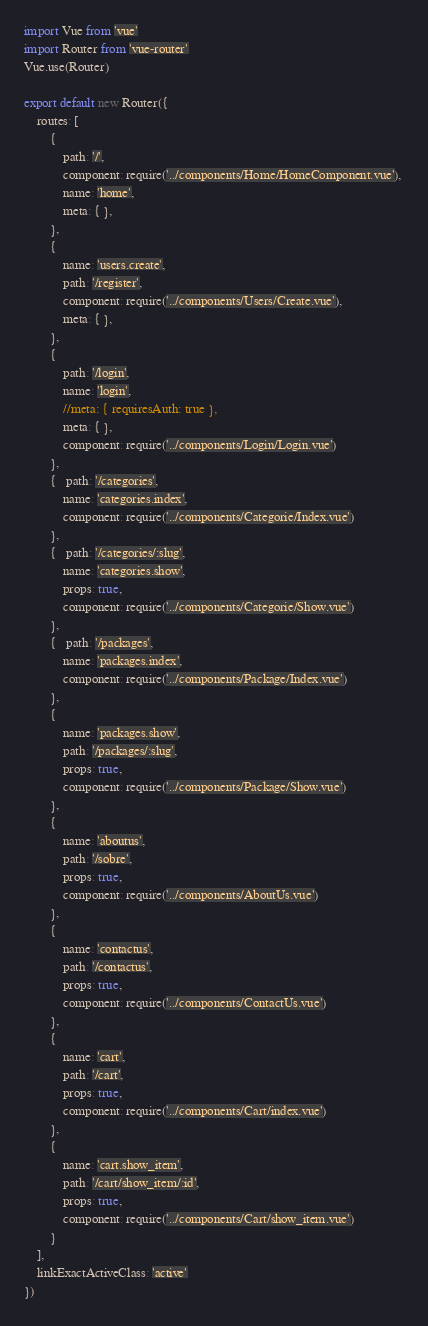<code> <loc_0><loc_0><loc_500><loc_500><_JavaScript_>import Vue from 'vue'
import Router from 'vue-router'
Vue.use(Router)

export default new Router({
  	routes: [
	    { 
	        path: '/', 
	        component: require('../components/Home/HomeComponent.vue'), 
	        name: 'home',
	        meta: { },
	    },
	    { 
	        name: 'users.create',
	        path: '/register', 
	        component: require('../components/Users/Create.vue'),
	        meta: { },
	    },
	    { 
	        path: '/login', 
	        name: 'login',
	        //meta: { requiresAuth: true },
	        meta: { },
	        component: require('../components/Login/Login.vue')
	    },
	    {   path: '/categories',
	        name: 'categories.index', 
	        component: require('../components/Categorie/Index.vue')
	    },    
	    {   path: '/categories/:slug',
	        name: 'categories.show', 
	        props: true,
	        component: require('../components/Categorie/Show.vue')
	    }, 
	    {   path: '/packages',
	        name: 'packages.index', 
	        component: require('../components/Package/Index.vue')
	    },
	    {
	        name: 'packages.show',
	        path: '/packages/:slug',
	        props: true,
	        component: require('../components/Package/Show.vue')
	    },
	    {
	        name: 'aboutus',
	        path: '/sobre',
	        props: true,
	        component: require('../components/AboutUs.vue')
	    },
	    {
	        name: 'contactus',
	        path: '/contactus',
	        props: true,
	        component: require('../components/ContactUs.vue')
	    },
	    {
	        name: 'cart',
	        path: '/cart',
	        props: true,
	        component: require('../components/Cart/index.vue')
	    },
	    {
	        name: 'cart.show_item',
	        path: '/cart/show_item/:id',
	        props: true,
	        component: require('../components/Cart/show_item.vue')
	    }
  	],
    linkExactActiveClass: 'active'
})
</code> 